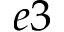Convert formula to latex. <formula><loc_0><loc_0><loc_500><loc_500>e 3</formula> 